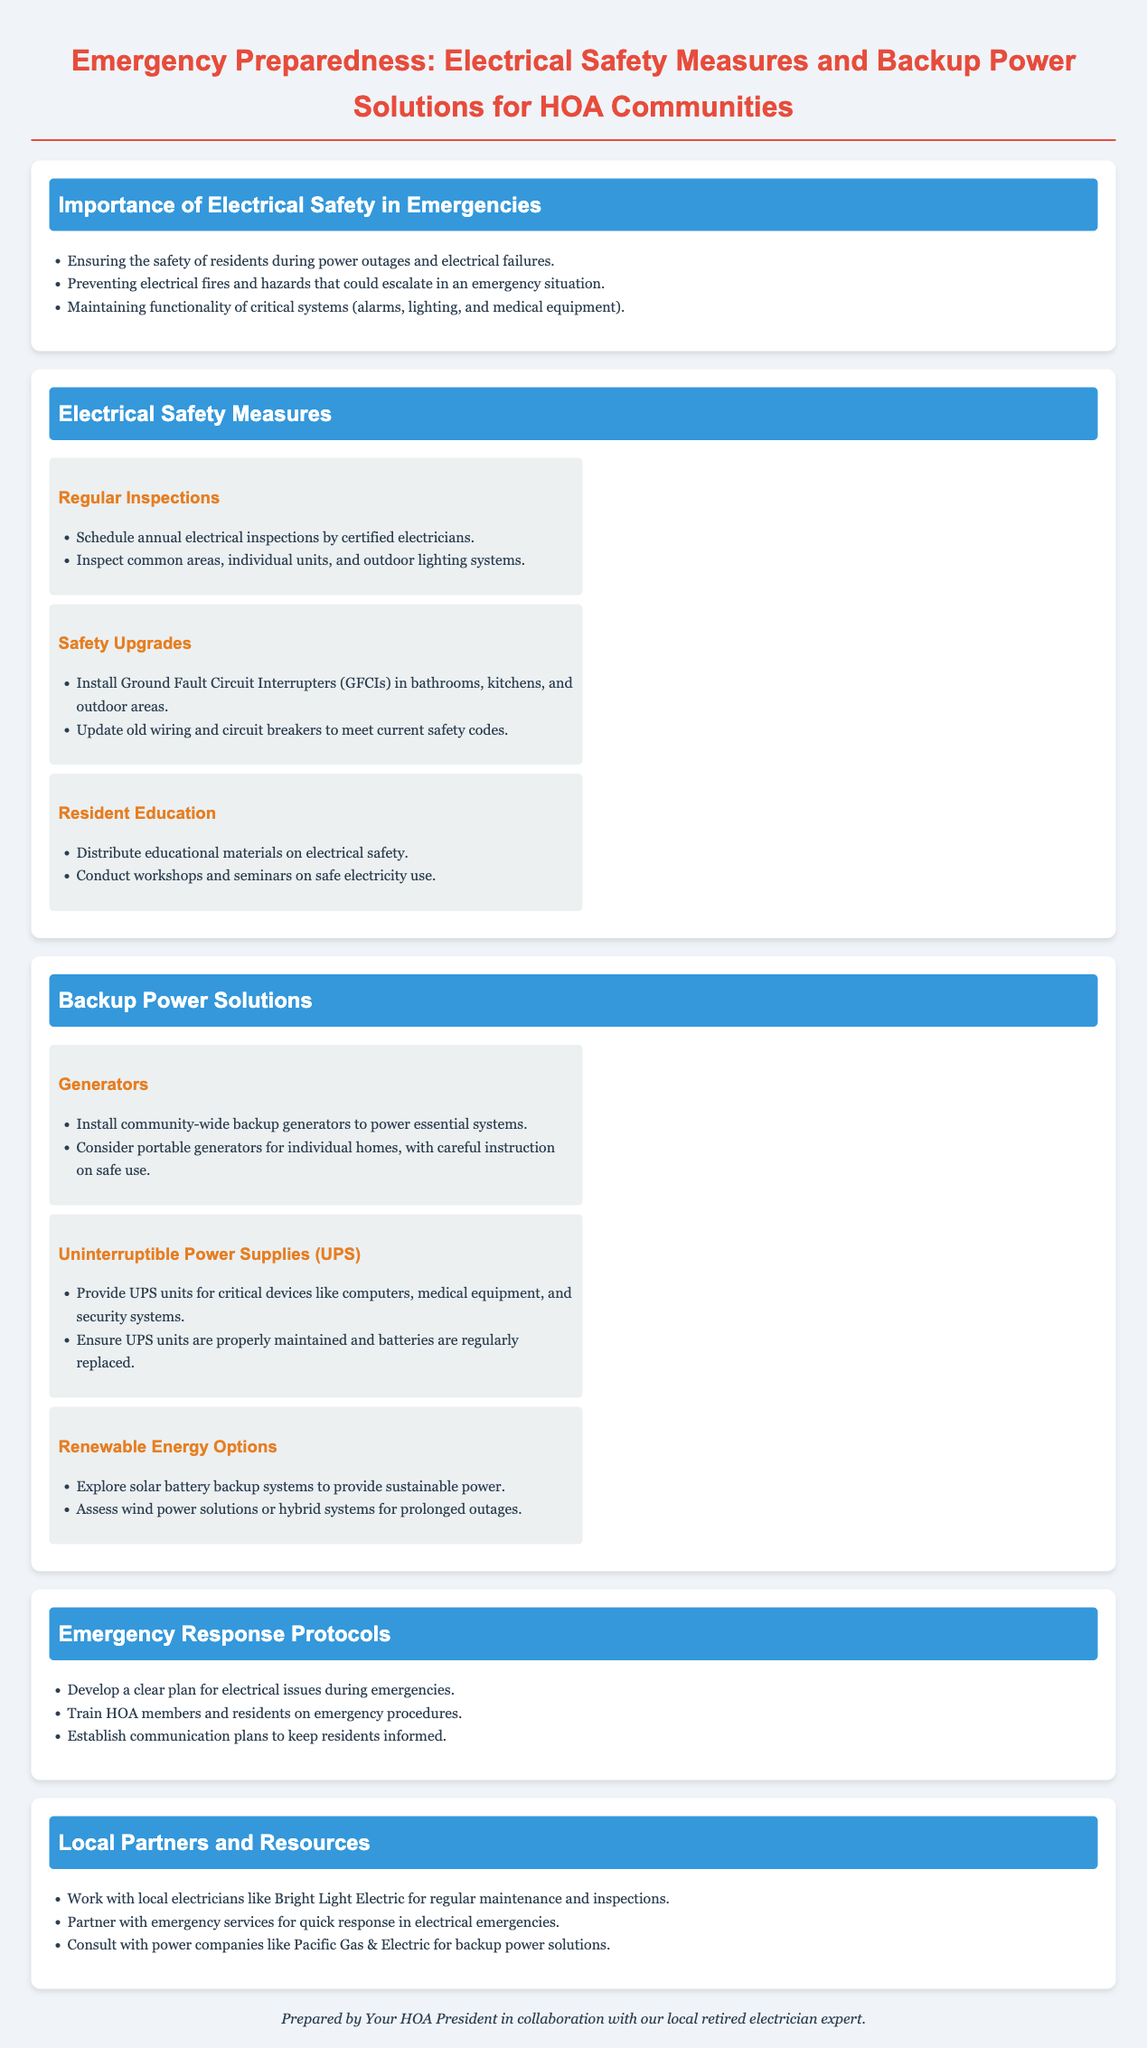what is the title of the document? The title is the main heading displayed prominently at the top of the document.
Answer: Emergency Preparedness: Electrical Safety Measures and Backup Power Solutions for HOA Communities how often should electrical inspections be conducted? The document specifies the suggested frequency for electrical inspections in the section on Electrical Safety Measures.
Answer: annually what are GFCIs? GFCIs are mentioned as a recommended safety upgrade in the Electrical Safety Measures section.
Answer: Ground Fault Circuit Interrupters name one backup power solution mentioned in the document. The document lists various backup power solutions under the Backup Power Solutions section.
Answer: Generators what should residents be educated about? The document discusses the importance of education for residents regarding a specific safety topic in the Electrical Safety Measures section.
Answer: electrical safety which local partner is mentioned for maintenance and inspections? The document lists local partners for various services in the Local Partners and Resources section.
Answer: Bright Light Electric what is one renewable energy option suggested? The document mentions renewable options that could be explored in the Backup Power Solutions section.
Answer: solar battery backup systems who should be trained on emergency procedures? The document outlines the importance of training in a specific context related to emergency response protocols.
Answer: HOA members and residents 